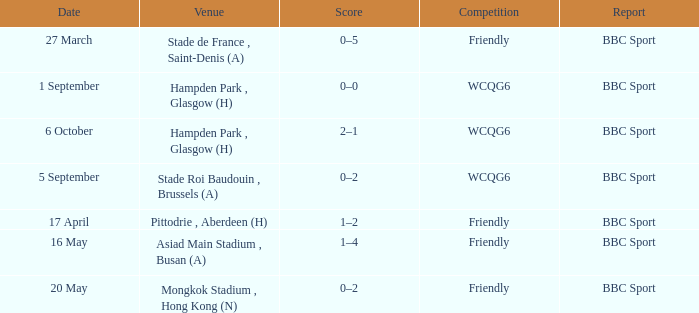Who reported the game on 6 october? BBC Sport. 